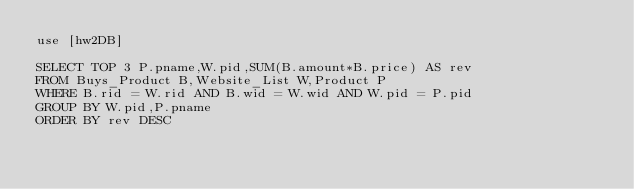Convert code to text. <code><loc_0><loc_0><loc_500><loc_500><_SQL_>use [hw2DB]

SELECT TOP 3 P.pname,W.pid,SUM(B.amount*B.price) AS rev
FROM Buys_Product B,Website_List W,Product P
WHERE B.rid = W.rid AND B.wid = W.wid AND W.pid = P.pid
GROUP BY W.pid,P.pname
ORDER BY rev DESC
</code> 